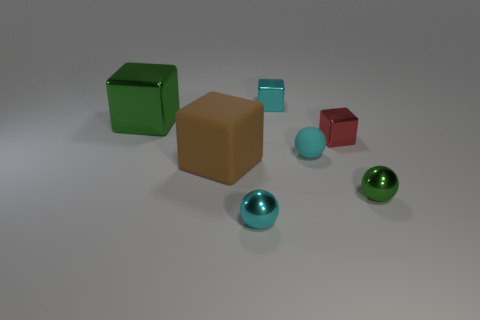What number of other things are the same material as the large brown block?
Provide a succinct answer. 1. How many tiny matte objects have the same shape as the small red shiny object?
Provide a succinct answer. 0. What is the color of the metallic block that is both to the left of the cyan matte sphere and right of the large green shiny cube?
Provide a succinct answer. Cyan. How many brown shiny spheres are there?
Offer a terse response. 0. Do the brown matte thing and the cyan shiny sphere have the same size?
Keep it short and to the point. No. Is there a object that has the same color as the rubber sphere?
Your answer should be compact. Yes. There is a small shiny object right of the red shiny block; is its shape the same as the large green thing?
Make the answer very short. No. What number of red things have the same size as the brown thing?
Your response must be concise. 0. How many metal spheres are behind the tiny cyan metal thing that is in front of the big green thing?
Your response must be concise. 1. Does the small sphere that is behind the brown matte cube have the same material as the big green cube?
Provide a short and direct response. No. 